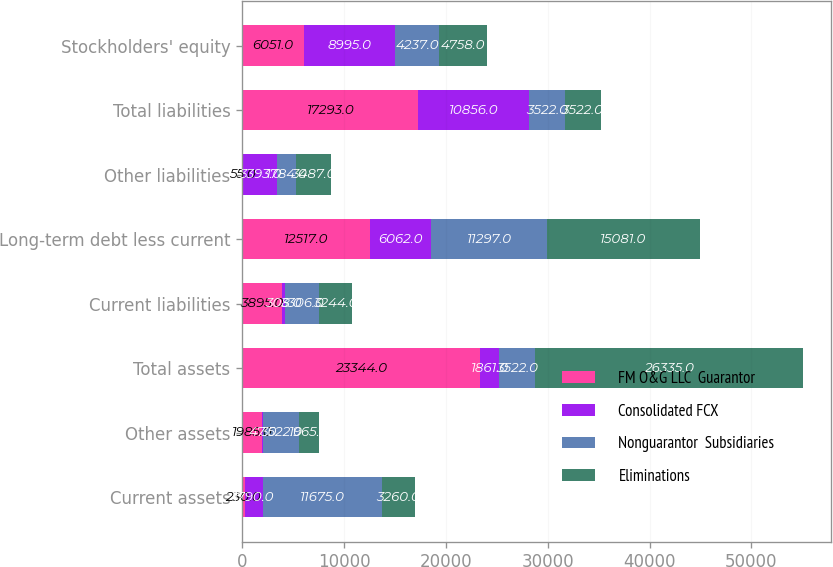<chart> <loc_0><loc_0><loc_500><loc_500><stacked_bar_chart><ecel><fcel>Current assets<fcel>Other assets<fcel>Total assets<fcel>Current liabilities<fcel>Long-term debt less current<fcel>Other liabilities<fcel>Total liabilities<fcel>Stockholders' equity<nl><fcel>FM O&G LLC  Guarantor<fcel>230<fcel>1985<fcel>23344<fcel>3895<fcel>12517<fcel>55<fcel>17293<fcel>6051<nl><fcel>Consolidated FCX<fcel>1790<fcel>47<fcel>1861<fcel>308<fcel>6062<fcel>3393<fcel>10856<fcel>8995<nl><fcel>Nonguarantor  Subsidiaries<fcel>11675<fcel>3522<fcel>3522<fcel>3306<fcel>11297<fcel>1784<fcel>3522<fcel>4237<nl><fcel>Eliminations<fcel>3260<fcel>1965<fcel>26335<fcel>3244<fcel>15081<fcel>3487<fcel>3522<fcel>4758<nl></chart> 